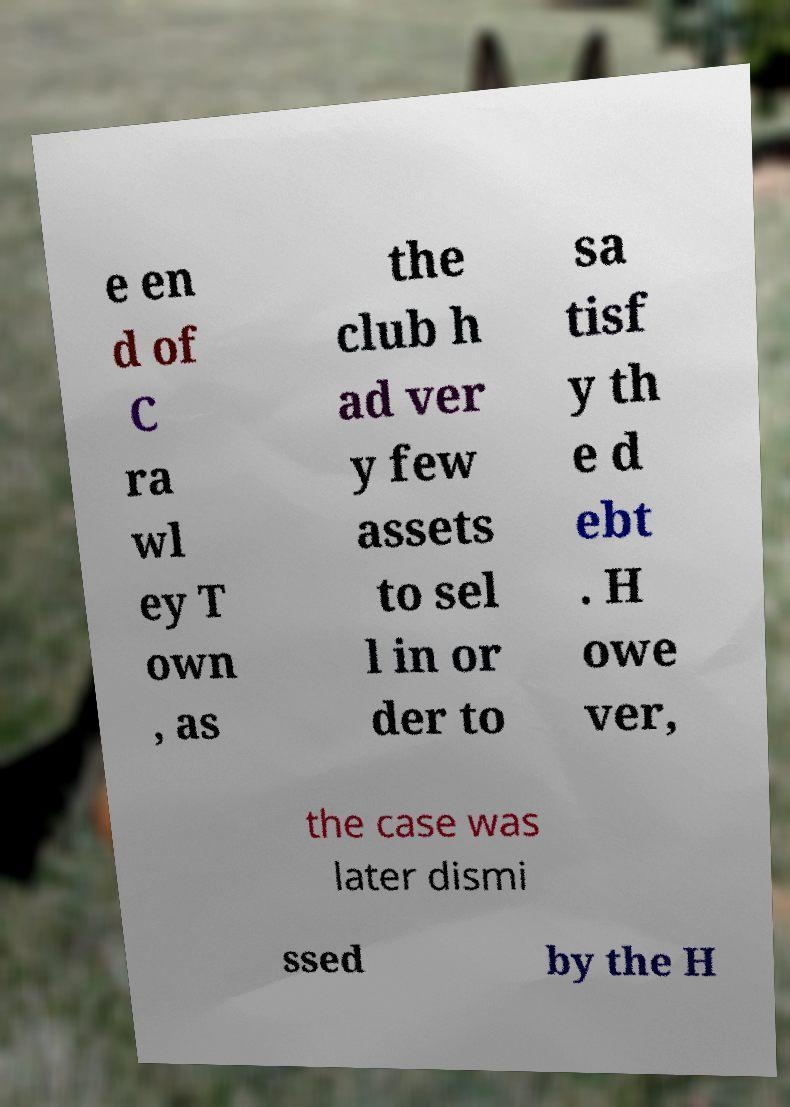Can you read and provide the text displayed in the image?This photo seems to have some interesting text. Can you extract and type it out for me? e en d of C ra wl ey T own , as the club h ad ver y few assets to sel l in or der to sa tisf y th e d ebt . H owe ver, the case was later dismi ssed by the H 